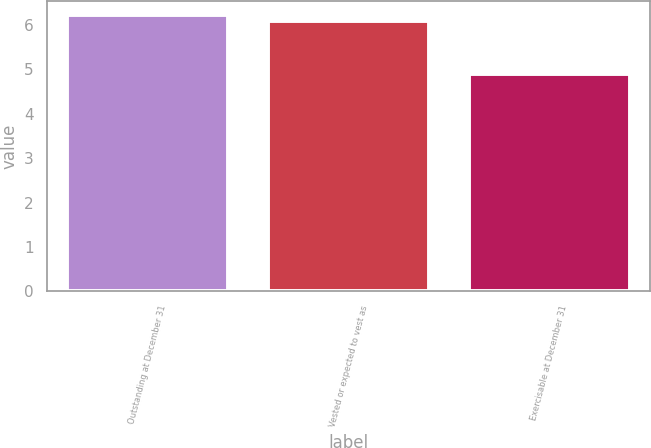<chart> <loc_0><loc_0><loc_500><loc_500><bar_chart><fcel>Outstanding at December 31<fcel>Vested or expected to vest as<fcel>Exercisable at December 31<nl><fcel>6.23<fcel>6.1<fcel>4.9<nl></chart> 